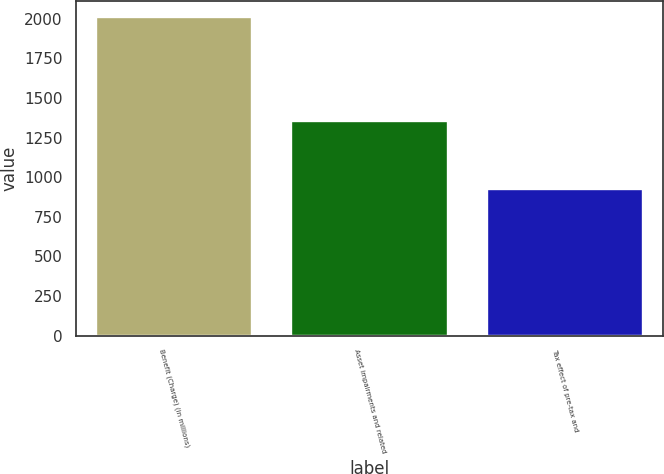Convert chart. <chart><loc_0><loc_0><loc_500><loc_500><bar_chart><fcel>Benefit (Charge) (in millions)<fcel>Asset impairments and related<fcel>Tax effect of pre-tax and<nl><fcel>2014<fcel>1358<fcel>927<nl></chart> 